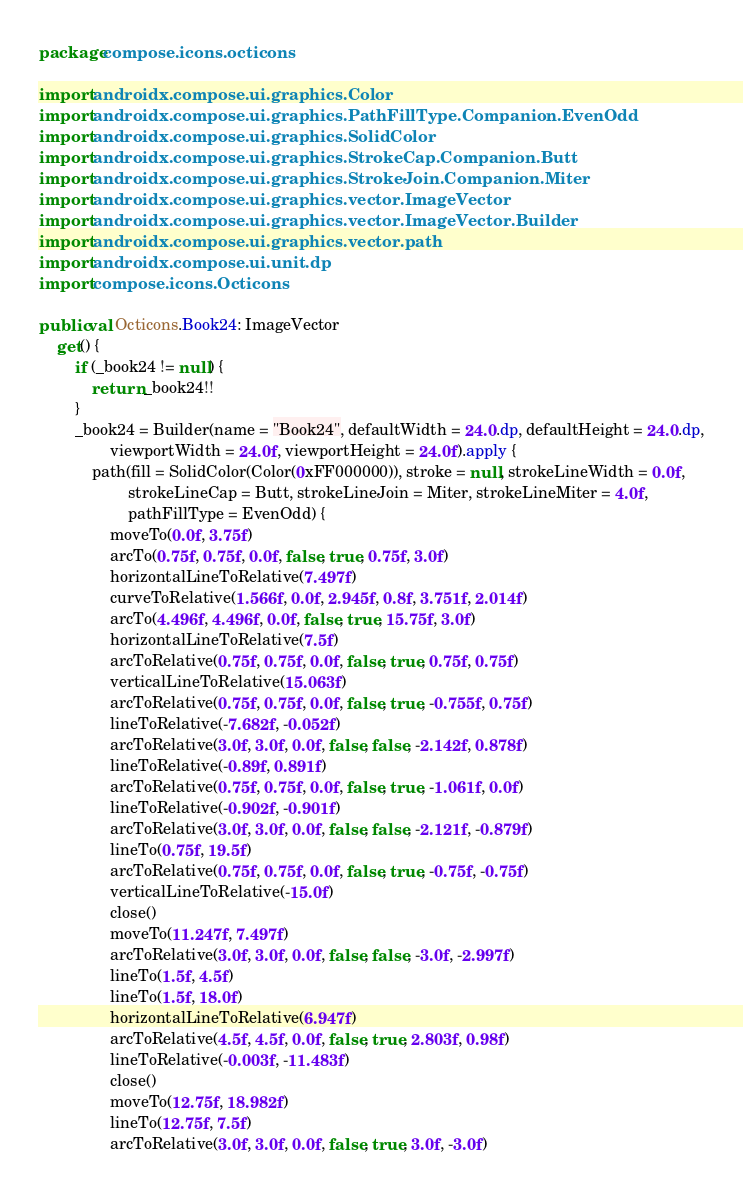<code> <loc_0><loc_0><loc_500><loc_500><_Kotlin_>package compose.icons.octicons

import androidx.compose.ui.graphics.Color
import androidx.compose.ui.graphics.PathFillType.Companion.EvenOdd
import androidx.compose.ui.graphics.SolidColor
import androidx.compose.ui.graphics.StrokeCap.Companion.Butt
import androidx.compose.ui.graphics.StrokeJoin.Companion.Miter
import androidx.compose.ui.graphics.vector.ImageVector
import androidx.compose.ui.graphics.vector.ImageVector.Builder
import androidx.compose.ui.graphics.vector.path
import androidx.compose.ui.unit.dp
import compose.icons.Octicons

public val Octicons.Book24: ImageVector
    get() {
        if (_book24 != null) {
            return _book24!!
        }
        _book24 = Builder(name = "Book24", defaultWidth = 24.0.dp, defaultHeight = 24.0.dp,
                viewportWidth = 24.0f, viewportHeight = 24.0f).apply {
            path(fill = SolidColor(Color(0xFF000000)), stroke = null, strokeLineWidth = 0.0f,
                    strokeLineCap = Butt, strokeLineJoin = Miter, strokeLineMiter = 4.0f,
                    pathFillType = EvenOdd) {
                moveTo(0.0f, 3.75f)
                arcTo(0.75f, 0.75f, 0.0f, false, true, 0.75f, 3.0f)
                horizontalLineToRelative(7.497f)
                curveToRelative(1.566f, 0.0f, 2.945f, 0.8f, 3.751f, 2.014f)
                arcTo(4.496f, 4.496f, 0.0f, false, true, 15.75f, 3.0f)
                horizontalLineToRelative(7.5f)
                arcToRelative(0.75f, 0.75f, 0.0f, false, true, 0.75f, 0.75f)
                verticalLineToRelative(15.063f)
                arcToRelative(0.75f, 0.75f, 0.0f, false, true, -0.755f, 0.75f)
                lineToRelative(-7.682f, -0.052f)
                arcToRelative(3.0f, 3.0f, 0.0f, false, false, -2.142f, 0.878f)
                lineToRelative(-0.89f, 0.891f)
                arcToRelative(0.75f, 0.75f, 0.0f, false, true, -1.061f, 0.0f)
                lineToRelative(-0.902f, -0.901f)
                arcToRelative(3.0f, 3.0f, 0.0f, false, false, -2.121f, -0.879f)
                lineTo(0.75f, 19.5f)
                arcToRelative(0.75f, 0.75f, 0.0f, false, true, -0.75f, -0.75f)
                verticalLineToRelative(-15.0f)
                close()
                moveTo(11.247f, 7.497f)
                arcToRelative(3.0f, 3.0f, 0.0f, false, false, -3.0f, -2.997f)
                lineTo(1.5f, 4.5f)
                lineTo(1.5f, 18.0f)
                horizontalLineToRelative(6.947f)
                arcToRelative(4.5f, 4.5f, 0.0f, false, true, 2.803f, 0.98f)
                lineToRelative(-0.003f, -11.483f)
                close()
                moveTo(12.75f, 18.982f)
                lineTo(12.75f, 7.5f)
                arcToRelative(3.0f, 3.0f, 0.0f, false, true, 3.0f, -3.0f)</code> 